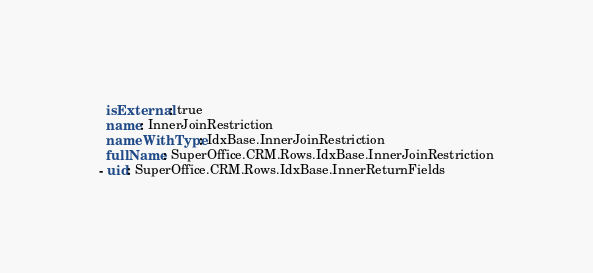<code> <loc_0><loc_0><loc_500><loc_500><_YAML_>  isExternal: true
  name: InnerJoinRestriction
  nameWithType: IdxBase.InnerJoinRestriction
  fullName: SuperOffice.CRM.Rows.IdxBase.InnerJoinRestriction
- uid: SuperOffice.CRM.Rows.IdxBase.InnerReturnFields</code> 